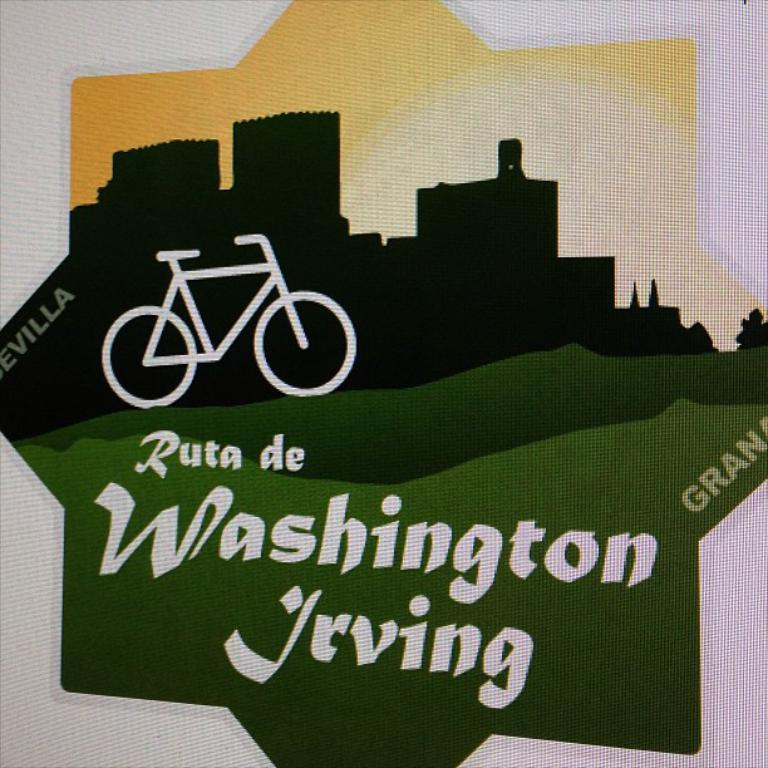What is the main feature in the center of the image? There is a logo in the center of the image. What can be found within the logo? The logo contains text and depictions of buildings and cycles. What type of linen is used to create the background of the logo? There is no mention of linen being used in the image or the logo; it is not present. 